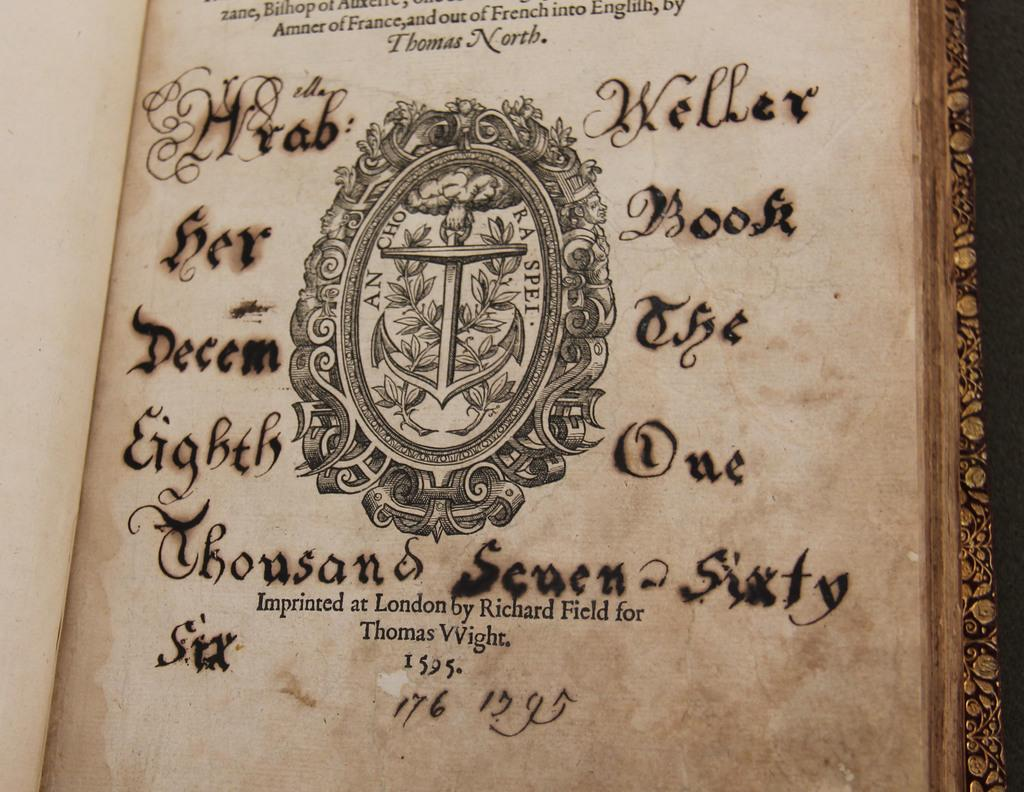<image>
Describe the image concisely. A very old and yellowed book that was imprinted at London by Richard field for Thomas Wight 